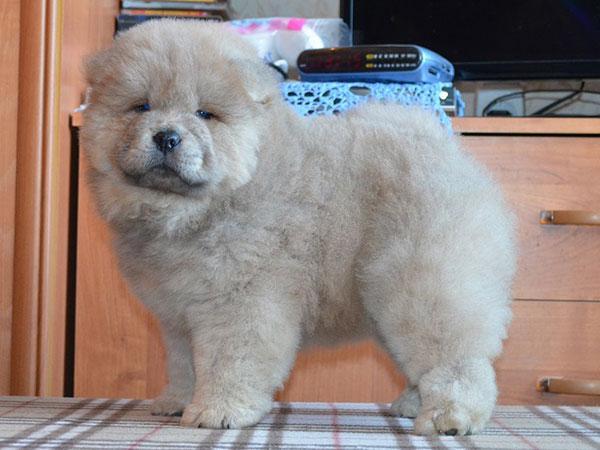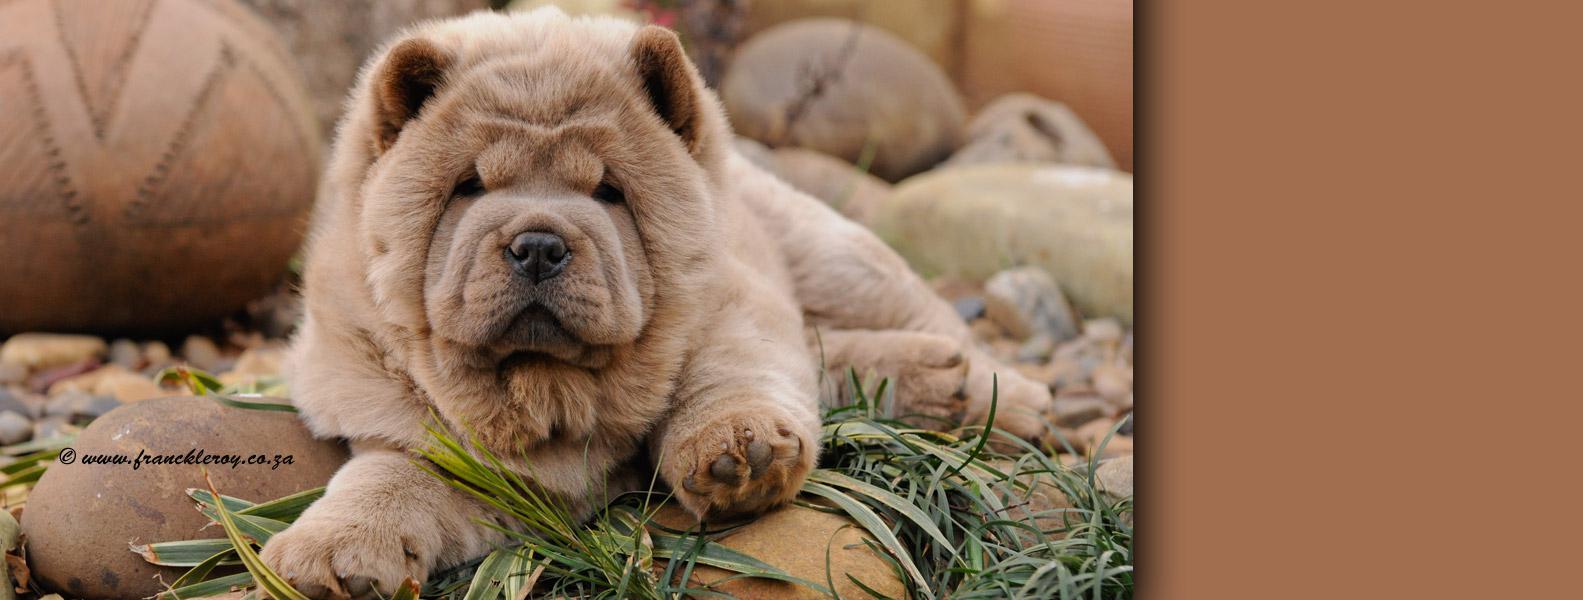The first image is the image on the left, the second image is the image on the right. Given the left and right images, does the statement "There are two dogs standing on four legs." hold true? Answer yes or no. No. The first image is the image on the left, the second image is the image on the right. Given the left and right images, does the statement "One image features a person behind a chow posed standing on all fours and looking toward the camera." hold true? Answer yes or no. No. 